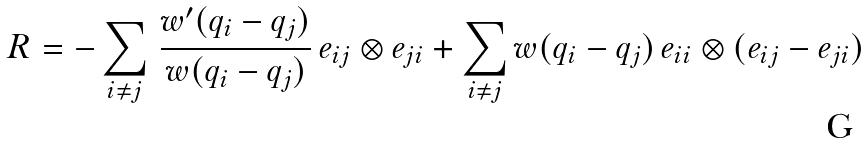Convert formula to latex. <formula><loc_0><loc_0><loc_500><loc_500>R = - \sum _ { i \neq j } \, \frac { w ^ { \prime } ( q _ { i } - q _ { j } ) } { w ( q _ { i } - q _ { j } ) } \, e _ { i j } \otimes e _ { j i } + \sum _ { i \neq j } w ( q _ { i } - q _ { j } ) \, e _ { i i } \otimes ( e _ { i j } - e _ { j i } )</formula> 